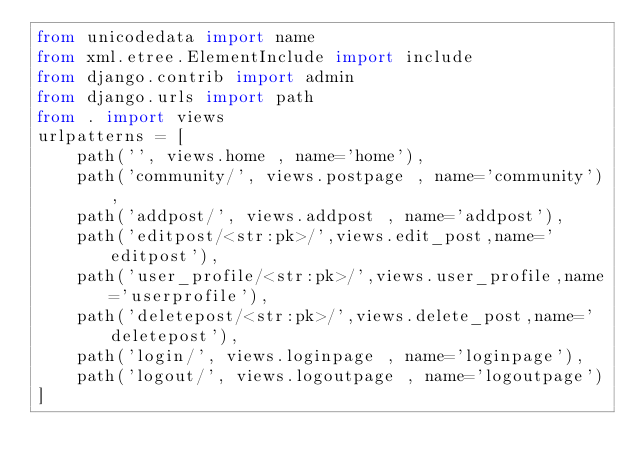Convert code to text. <code><loc_0><loc_0><loc_500><loc_500><_Python_>from unicodedata import name
from xml.etree.ElementInclude import include
from django.contrib import admin
from django.urls import path
from . import views
urlpatterns = [
    path('', views.home , name='home'),
    path('community/', views.postpage , name='community'),
    path('addpost/', views.addpost , name='addpost'),
    path('editpost/<str:pk>/',views.edit_post,name='editpost'),
    path('user_profile/<str:pk>/',views.user_profile,name='userprofile'),
    path('deletepost/<str:pk>/',views.delete_post,name='deletepost'),
    path('login/', views.loginpage , name='loginpage'),
    path('logout/', views.logoutpage , name='logoutpage')
]
</code> 